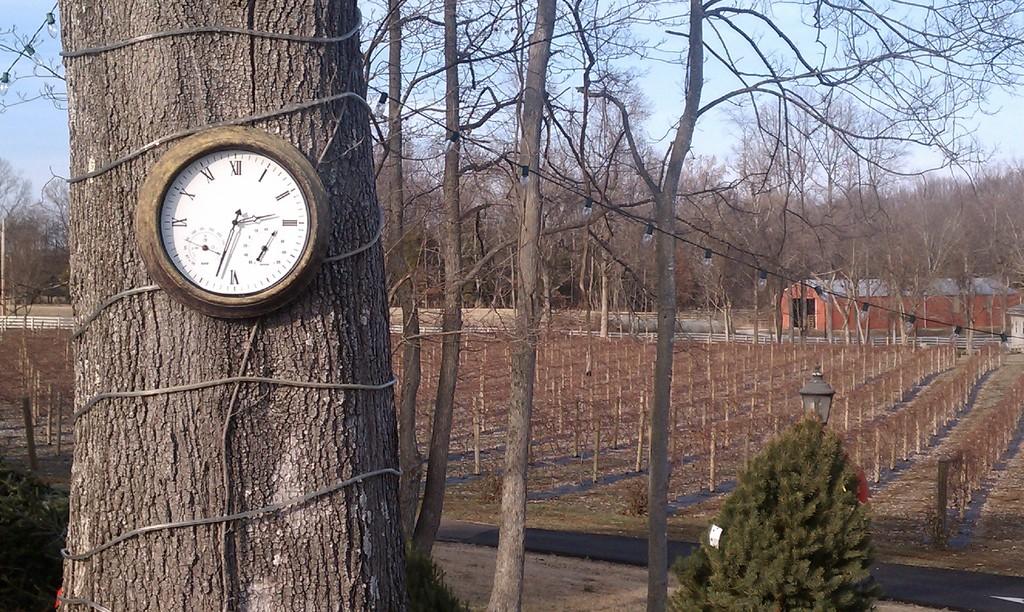What time is it?
Your response must be concise. 2:33. What roman number has the long hand just passed?
Offer a terse response. Vi. 